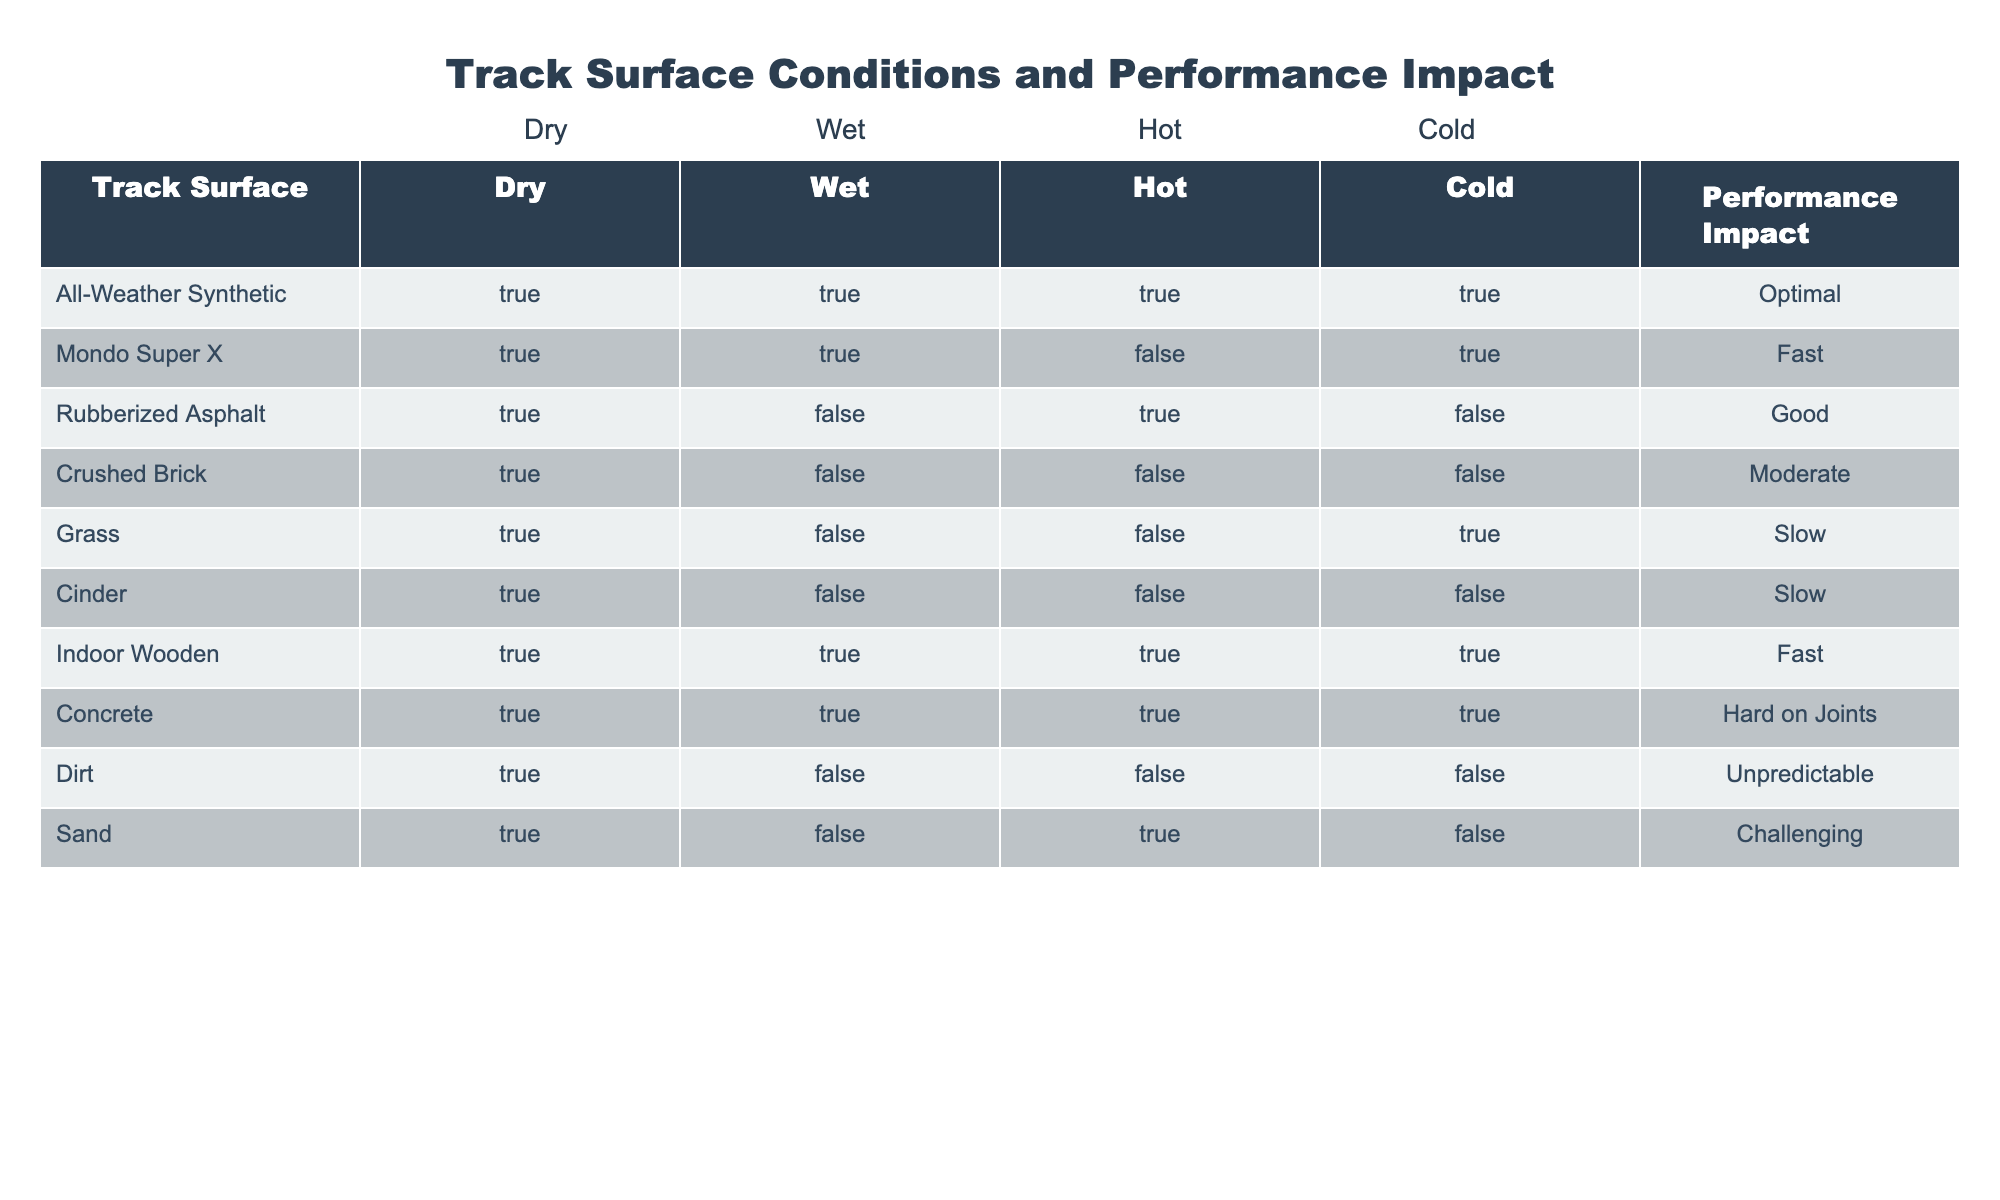What is the performance impact of All-Weather Synthetic track? According to the table, the performance impact for All-Weather Synthetic track is listed as 'Optimal'.
Answer: Optimal How does the performance impact of Mondo Super X track compare to that of Indoor Wooden track? Both Mondo Super X and Indoor Wooden tracks have a performance impact categorized as 'Fast'. Thus, they are similar regarding this measure.
Answer: Fast Is the performance on Grass track impacted by cold conditions? The table indicates that for Grass track, the performance impact is listed as 'Slow' with the condition being 'Cold' confirmed as true. Therefore, yes, it is impacted negatively.
Answer: Yes Which track surface does not perform well in wet conditions? The table shows that Rubberized Asphalt, Crushed Brick, Grass, Cinder, Dirt, and Sand all demonstrate issues in wet conditions, meaning they have 'False' under the 'Wet' column. Therefore, all these track surfaces do not perform well in wet conditions.
Answer: Rubberized Asphalt, Crushed Brick, Grass, Cinder, Dirt, Sand What is the average performance impact of track surfaces that are good on hot conditions? The performances recorded for surfaces with 'True' under hot conditions are 'Fast' (Mondo Super X), 'Good' (Rubberized Asphalt), 'Optimal' (All-Weather Synthetic), and 'Challenging' (Sand). Assigning numerical values (Optimal = 4, Fast = 3, Good = 2, Challenging = 1), the average would be (4 + 3 + 2 + 1) / 4 = 10 / 4 = 2.5, which corresponds to 'Good'.
Answer: Good Which track surface has the greatest performance negative impact? By examining the performance impacts, 'Unpredictable' and 'Challenging' appear to be the lowest rankings; however, 'Unpredictable' specifically indicates a greater negative impact than other categories, including 'Slow'. Therefore, it is the one with the most negative impact.
Answer: Dirt 